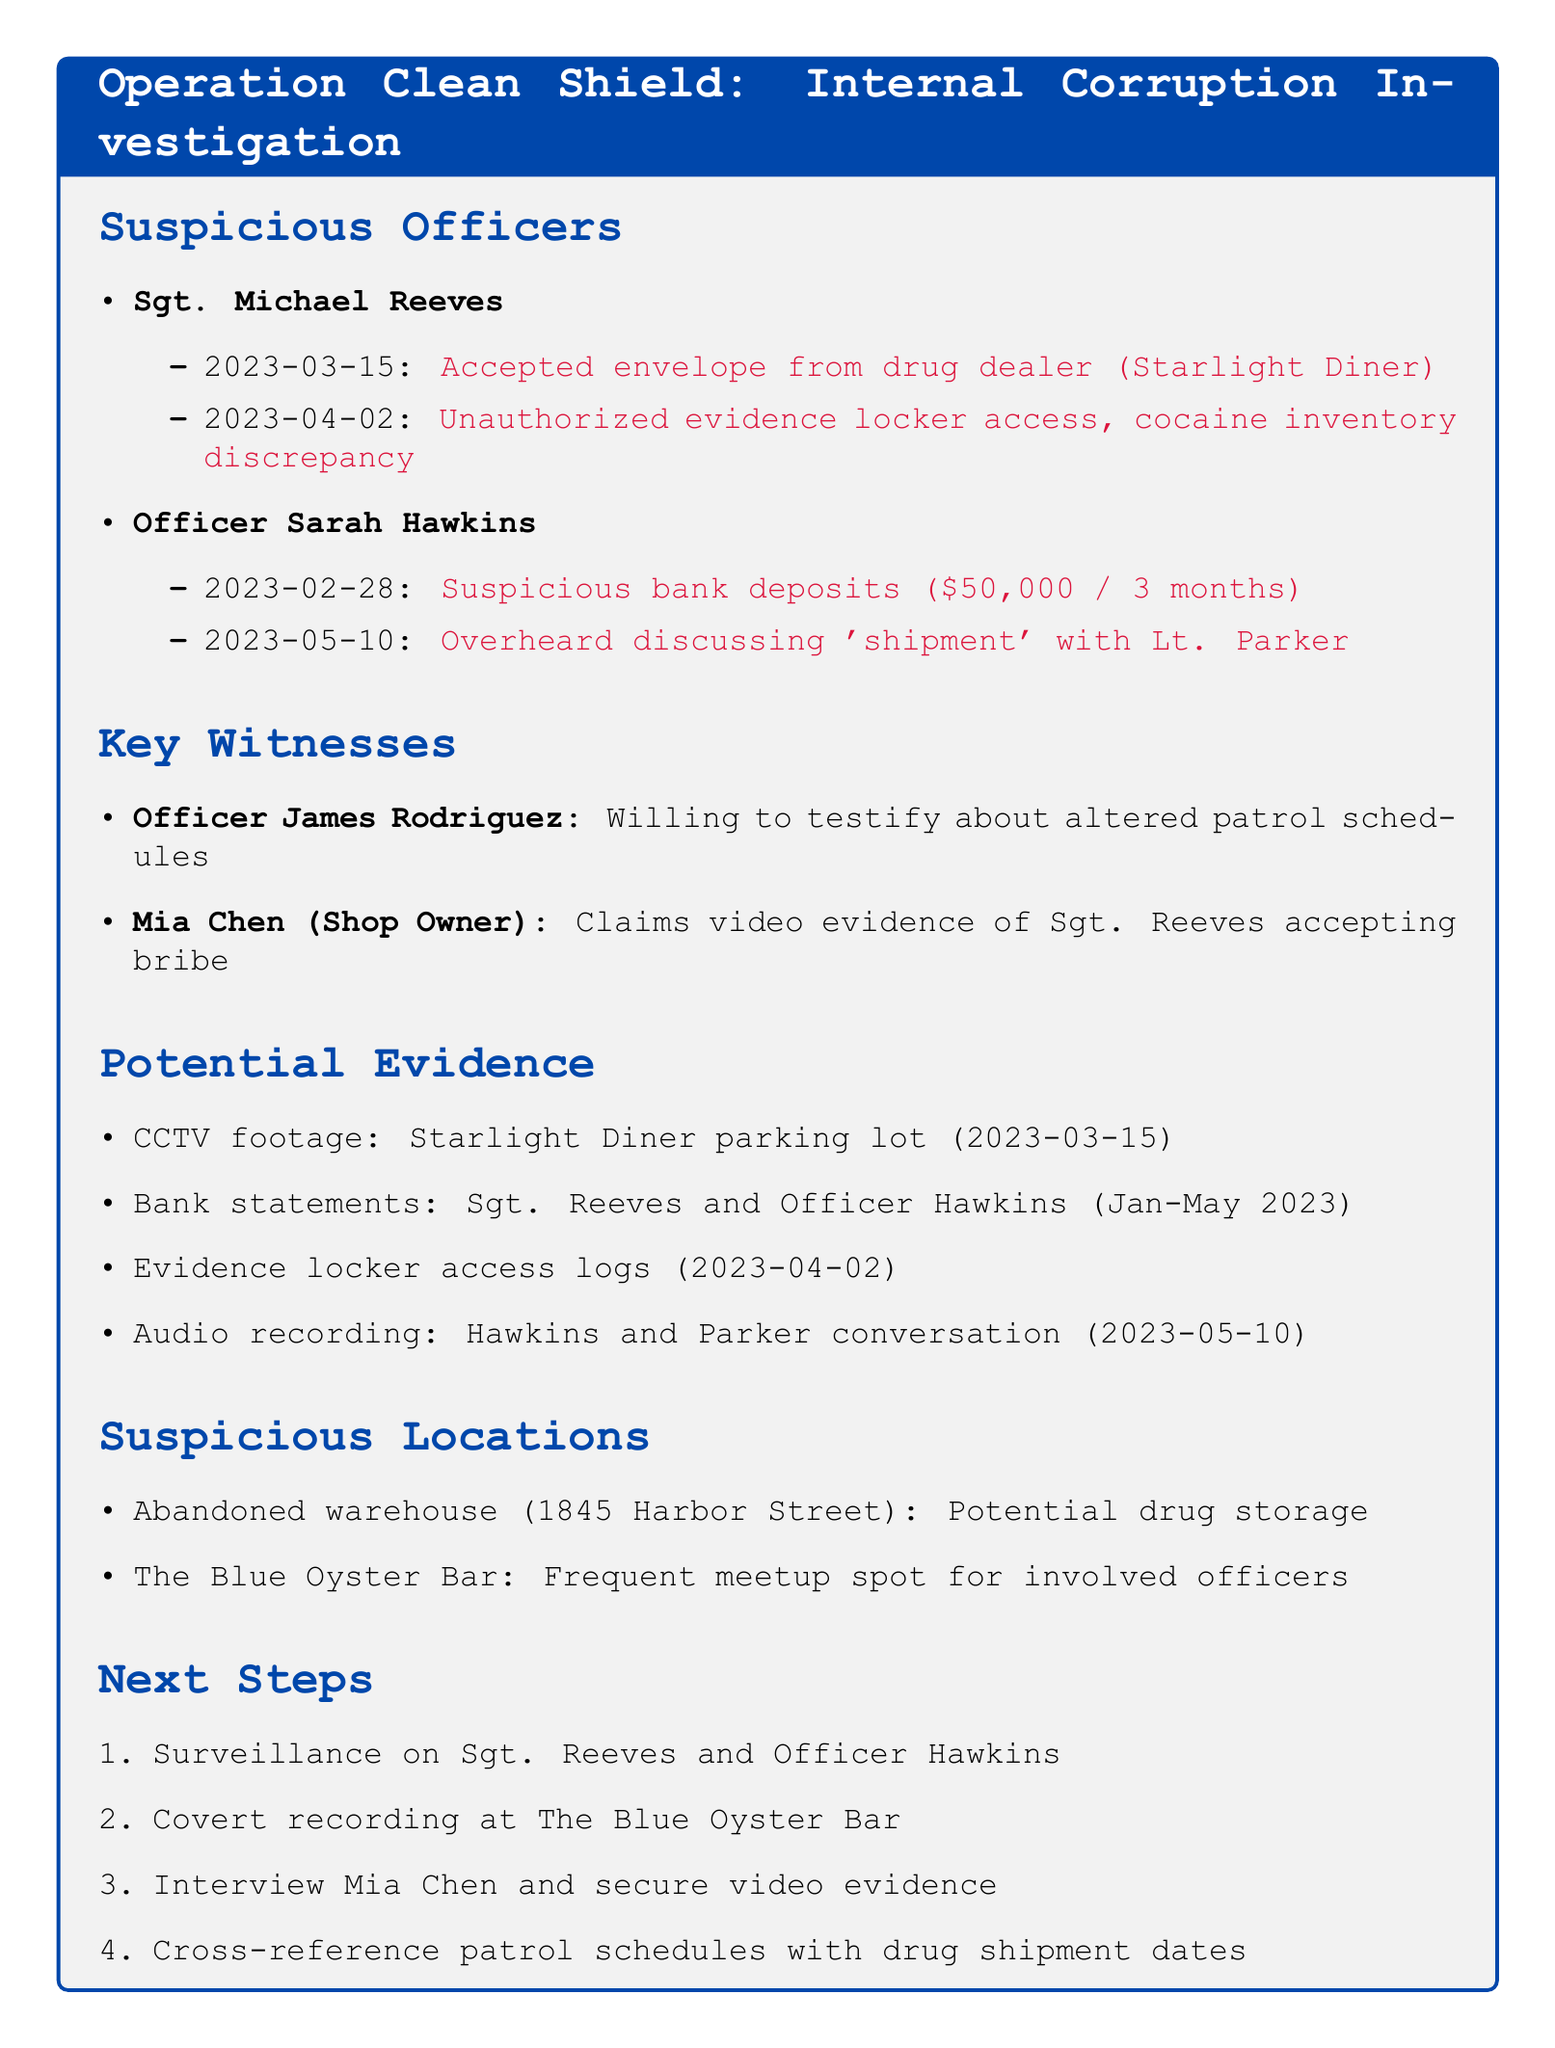What is the title of the case? The title of the case is mentioned at the beginning of the document under the Operation Clean Shield heading.
Answer: Operation Clean Shield: Internal Corruption Investigation Who is the key witness claiming to have video evidence? The document states that Mia Chen claims to have video evidence of Sgt. Reeves accepting a bribe.
Answer: Mia Chen On what date did Officer Sarah Hawkins have suspicious bank deposits? The document notes that the suspicious bank deposits were made over the span of three months, ending on February 28th, 2023.
Answer: 2023-02-28 What location is referred to as a potential drug storage? The document lists the abandoned warehouse at 1845 Harbor Street as a potential drug storage location.
Answer: Abandoned warehouse at 1845 Harbor Street What is one of the next steps in the investigation? The document outlines several next steps, and one of them is to surveil the suspicious officers.
Answer: Surveillance on Sgt. Reeves and Officer Hawkins How much money was involved in the suspicious bank deposits? The document specifies that the suspicious bank deposits totaled $50,000 over three months.
Answer: $50,000 What incident involves unauthorized evidence locker access? There is an incident mentioned regarding Sgt. Reeves on April 2nd, 2023, related to unauthorized access to evidence locker.
Answer: Unauthorized access to evidence locker, discrepancy in cocaine inventory Who was overheard discussing 'shipment'? The document indicates that Officer Sarah Hawkins was overheard discussing 'shipment' with Lieutenant Parker.
Answer: Officer Sarah Hawkins 